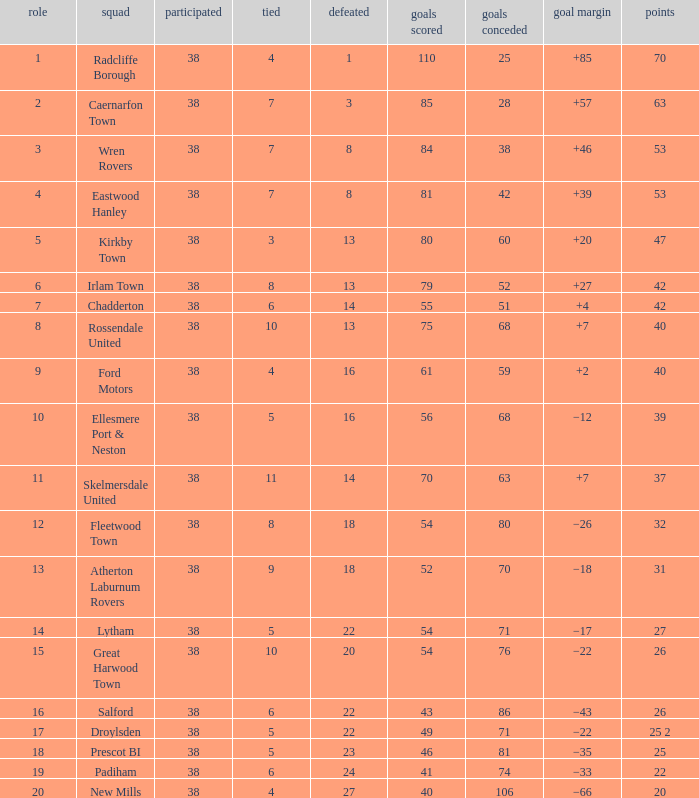Which Lost has a Position larger than 5, and Points 1 of 37, and less than 63 Goals Against? None. 